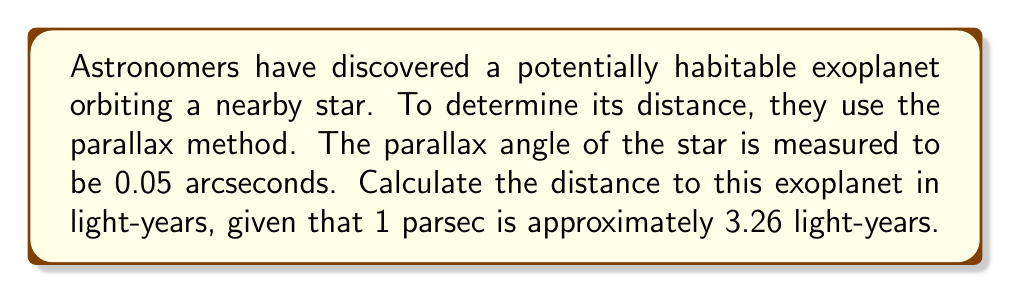Solve this math problem. To solve this problem, we'll follow these steps:

1) First, recall the relationship between parallax angle and distance in parsecs:

   $$ d = \frac{1}{p} $$

   where $d$ is the distance in parsecs and $p$ is the parallax angle in arcseconds.

2) We're given that the parallax angle is 0.05 arcseconds. Let's substitute this into our equation:

   $$ d = \frac{1}{0.05} = 20 \text{ parsecs} $$

3) Now we need to convert parsecs to light-years. We're given that 1 parsec is approximately 3.26 light-years. We can set up a simple proportion:

   $$ 1 \text{ parsec} = 3.26 \text{ light-years} $$
   $$ 20 \text{ parsecs} = x \text{ light-years} $$

4) Solve for $x$:

   $$ x = 20 \times 3.26 = 65.2 \text{ light-years} $$

Therefore, the potentially habitable exoplanet is approximately 65.2 light-years away from Earth.

This method is crucial for exoplanet research as it provides a way to measure stellar distances with high precision, which is essential for characterizing exoplanets and their potential habitability.
Answer: 65.2 light-years 